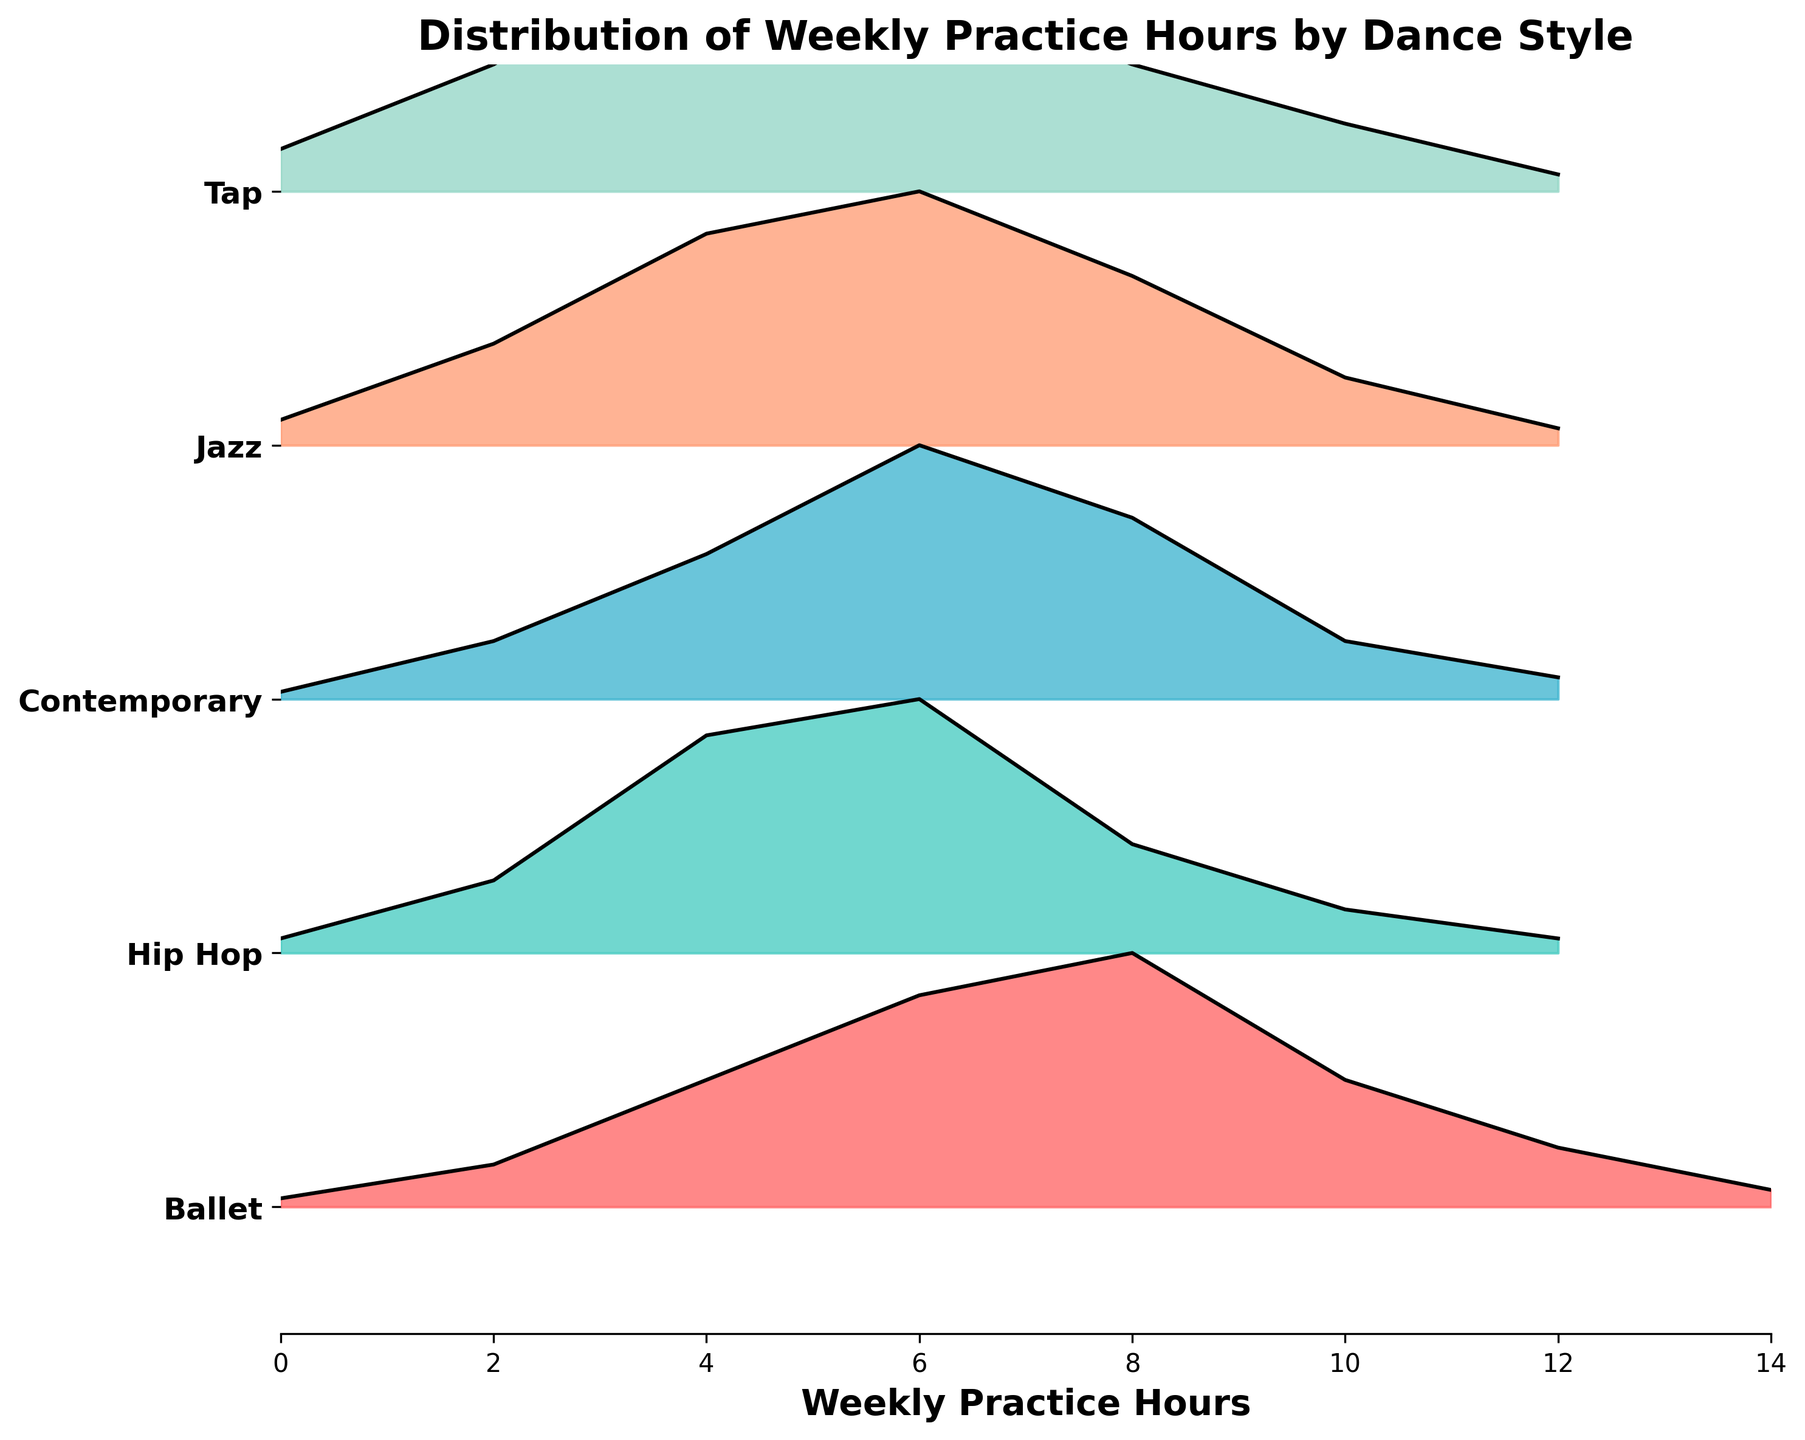Which dance style has the highest peak density? Upon examining the peaks of the ridgeline plots for each dance style, the peak density for Ballet stands out as the highest.
Answer: Ballet Which dance style has the lowest practice hours at its highest density point? By looking at the x-axis values at the highest density points for each dance style, Ballet and Hip Hop both have their highest density at 8 hours with Ballet having a density of 0.30 and Hip Hop at 0.35.
Answer: Ballet What is the total range of practice hours displayed on the x-axis? The x-axis shows practice hours ranging from 0 to 14.
Answer: 0 to 14 Which dance styles have a peak density at 6 hours of practice? By examining where the peak densities of each ridgeline plot occur, we see that Ballet, Hip Hop, Contemporary, and Jazz have their peaks at 6 hours of practice.
Answer: Ballet, Hip Hop, Contemporary, Jazz For which dance style is the distribution more spread out across different practice hours? By looking at the width and distribution of densities across the ridgeline plots, it is clear that Ballet and Contemporary have more spread-out distributions across the hours compared to the other dance styles.
Answer: Ballet, Contemporary Which dance style has its second-highest peak density at 4 hours of practice? By examining the densities at different practice hours, we see that Jazz has its second-highest peak density at 4 hours.
Answer: Jazz How does the peak density of Ballet compare with the peak density of Tap? Comparing the heights of the peak densities, Ballet's peak (0.30) is higher than Tap's peak (0.30).
Answer: They are equal At what practice hour do both Hip Hop and Contemporary reach their highest density? Both Hip Hop and Contemporary ridgelines reach their highest density at 6 hours of practice.
Answer: 6 hours What is the typical practice hour range that most students engage in for Jazz? Observing the ridgeline plot for Jazz, it seems that most students have practice hours ranging from 2 to 8 hours.
Answer: 2 to 8 hours How does the distribution for Ballet's practice hours differ from Hip Hop's practice hours? Ballet's distribution is more spread out with significant density starting from 2 hours to 12 hours, peaking at 8 hours. Hip Hop’s distribution is more concentrated, peaking at 6 hours and tapering off by 10 hours.
Answer: Ballet is more spread out, Hip Hop more concentrated 